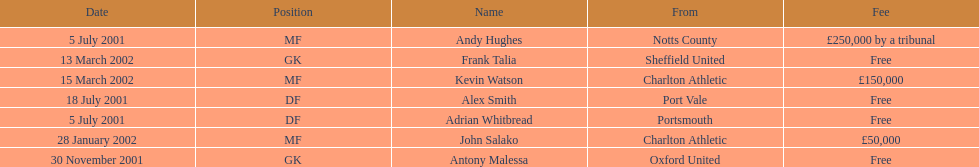Who transferred after 30 november 2001? John Salako, Frank Talia, Kevin Watson. 